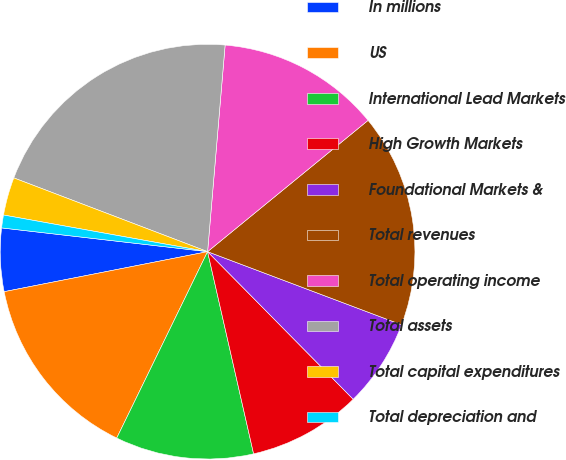<chart> <loc_0><loc_0><loc_500><loc_500><pie_chart><fcel>In millions<fcel>US<fcel>International Lead Markets<fcel>High Growth Markets<fcel>Foundational Markets &<fcel>Total revenues<fcel>Total operating income<fcel>Total assets<fcel>Total capital expenditures<fcel>Total depreciation and<nl><fcel>4.92%<fcel>14.69%<fcel>10.78%<fcel>8.83%<fcel>6.87%<fcel>16.65%<fcel>12.74%<fcel>20.56%<fcel>2.96%<fcel>1.0%<nl></chart> 